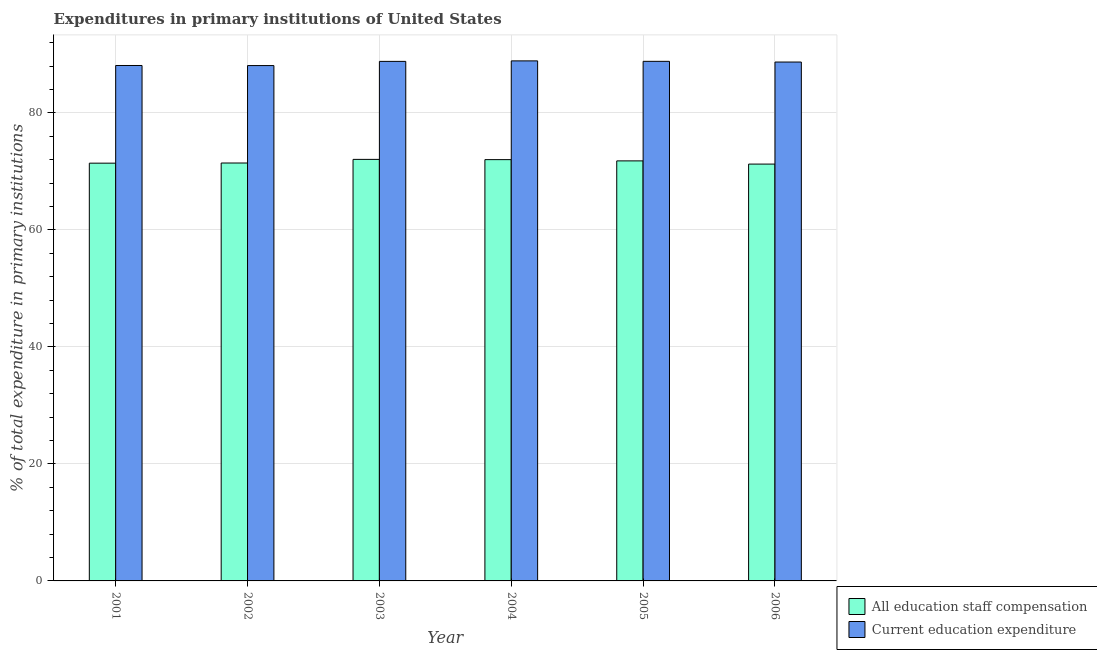How many different coloured bars are there?
Your answer should be very brief. 2. How many bars are there on the 4th tick from the right?
Provide a short and direct response. 2. What is the label of the 1st group of bars from the left?
Make the answer very short. 2001. In how many cases, is the number of bars for a given year not equal to the number of legend labels?
Offer a very short reply. 0. What is the expenditure in education in 2001?
Provide a short and direct response. 88.1. Across all years, what is the maximum expenditure in education?
Your answer should be compact. 88.89. Across all years, what is the minimum expenditure in education?
Your answer should be compact. 88.09. In which year was the expenditure in staff compensation maximum?
Provide a succinct answer. 2003. In which year was the expenditure in staff compensation minimum?
Provide a short and direct response. 2006. What is the total expenditure in staff compensation in the graph?
Your answer should be very brief. 429.93. What is the difference between the expenditure in staff compensation in 2003 and that in 2004?
Make the answer very short. 0.04. What is the difference between the expenditure in education in 2001 and the expenditure in staff compensation in 2002?
Your answer should be compact. 0.01. What is the average expenditure in staff compensation per year?
Offer a terse response. 71.66. In the year 2005, what is the difference between the expenditure in staff compensation and expenditure in education?
Offer a terse response. 0. What is the ratio of the expenditure in staff compensation in 2002 to that in 2004?
Give a very brief answer. 0.99. Is the expenditure in staff compensation in 2002 less than that in 2003?
Your answer should be very brief. Yes. What is the difference between the highest and the second highest expenditure in staff compensation?
Provide a succinct answer. 0.04. What is the difference between the highest and the lowest expenditure in staff compensation?
Make the answer very short. 0.8. In how many years, is the expenditure in education greater than the average expenditure in education taken over all years?
Your response must be concise. 4. What does the 1st bar from the left in 2002 represents?
Give a very brief answer. All education staff compensation. What does the 1st bar from the right in 2001 represents?
Ensure brevity in your answer.  Current education expenditure. What is the difference between two consecutive major ticks on the Y-axis?
Keep it short and to the point. 20. Are the values on the major ticks of Y-axis written in scientific E-notation?
Your answer should be compact. No. Does the graph contain any zero values?
Your response must be concise. No. How many legend labels are there?
Keep it short and to the point. 2. What is the title of the graph?
Offer a terse response. Expenditures in primary institutions of United States. Does "Under-five" appear as one of the legend labels in the graph?
Offer a very short reply. No. What is the label or title of the X-axis?
Your answer should be compact. Year. What is the label or title of the Y-axis?
Your answer should be compact. % of total expenditure in primary institutions. What is the % of total expenditure in primary institutions in All education staff compensation in 2001?
Your answer should be very brief. 71.4. What is the % of total expenditure in primary institutions in Current education expenditure in 2001?
Your answer should be compact. 88.1. What is the % of total expenditure in primary institutions of All education staff compensation in 2002?
Offer a very short reply. 71.43. What is the % of total expenditure in primary institutions of Current education expenditure in 2002?
Provide a short and direct response. 88.09. What is the % of total expenditure in primary institutions in All education staff compensation in 2003?
Give a very brief answer. 72.05. What is the % of total expenditure in primary institutions in Current education expenditure in 2003?
Your answer should be very brief. 88.8. What is the % of total expenditure in primary institutions in All education staff compensation in 2004?
Provide a succinct answer. 72.01. What is the % of total expenditure in primary institutions of Current education expenditure in 2004?
Provide a short and direct response. 88.89. What is the % of total expenditure in primary institutions of All education staff compensation in 2005?
Your answer should be very brief. 71.79. What is the % of total expenditure in primary institutions of Current education expenditure in 2005?
Your response must be concise. 88.81. What is the % of total expenditure in primary institutions of All education staff compensation in 2006?
Provide a succinct answer. 71.25. What is the % of total expenditure in primary institutions of Current education expenditure in 2006?
Provide a short and direct response. 88.69. Across all years, what is the maximum % of total expenditure in primary institutions of All education staff compensation?
Provide a short and direct response. 72.05. Across all years, what is the maximum % of total expenditure in primary institutions of Current education expenditure?
Offer a very short reply. 88.89. Across all years, what is the minimum % of total expenditure in primary institutions in All education staff compensation?
Your answer should be compact. 71.25. Across all years, what is the minimum % of total expenditure in primary institutions in Current education expenditure?
Your answer should be compact. 88.09. What is the total % of total expenditure in primary institutions in All education staff compensation in the graph?
Make the answer very short. 429.93. What is the total % of total expenditure in primary institutions of Current education expenditure in the graph?
Provide a short and direct response. 531.37. What is the difference between the % of total expenditure in primary institutions of All education staff compensation in 2001 and that in 2002?
Keep it short and to the point. -0.03. What is the difference between the % of total expenditure in primary institutions of Current education expenditure in 2001 and that in 2002?
Your answer should be very brief. 0.01. What is the difference between the % of total expenditure in primary institutions of All education staff compensation in 2001 and that in 2003?
Keep it short and to the point. -0.65. What is the difference between the % of total expenditure in primary institutions of Current education expenditure in 2001 and that in 2003?
Keep it short and to the point. -0.7. What is the difference between the % of total expenditure in primary institutions in All education staff compensation in 2001 and that in 2004?
Keep it short and to the point. -0.6. What is the difference between the % of total expenditure in primary institutions of Current education expenditure in 2001 and that in 2004?
Give a very brief answer. -0.79. What is the difference between the % of total expenditure in primary institutions in All education staff compensation in 2001 and that in 2005?
Keep it short and to the point. -0.39. What is the difference between the % of total expenditure in primary institutions in Current education expenditure in 2001 and that in 2005?
Your response must be concise. -0.71. What is the difference between the % of total expenditure in primary institutions in All education staff compensation in 2001 and that in 2006?
Your response must be concise. 0.16. What is the difference between the % of total expenditure in primary institutions in Current education expenditure in 2001 and that in 2006?
Your response must be concise. -0.59. What is the difference between the % of total expenditure in primary institutions of All education staff compensation in 2002 and that in 2003?
Provide a short and direct response. -0.62. What is the difference between the % of total expenditure in primary institutions in Current education expenditure in 2002 and that in 2003?
Keep it short and to the point. -0.71. What is the difference between the % of total expenditure in primary institutions in All education staff compensation in 2002 and that in 2004?
Offer a very short reply. -0.57. What is the difference between the % of total expenditure in primary institutions of Current education expenditure in 2002 and that in 2004?
Your answer should be very brief. -0.8. What is the difference between the % of total expenditure in primary institutions of All education staff compensation in 2002 and that in 2005?
Ensure brevity in your answer.  -0.36. What is the difference between the % of total expenditure in primary institutions of Current education expenditure in 2002 and that in 2005?
Your response must be concise. -0.72. What is the difference between the % of total expenditure in primary institutions of All education staff compensation in 2002 and that in 2006?
Your response must be concise. 0.18. What is the difference between the % of total expenditure in primary institutions of Current education expenditure in 2002 and that in 2006?
Provide a short and direct response. -0.6. What is the difference between the % of total expenditure in primary institutions of All education staff compensation in 2003 and that in 2004?
Give a very brief answer. 0.04. What is the difference between the % of total expenditure in primary institutions in Current education expenditure in 2003 and that in 2004?
Provide a succinct answer. -0.09. What is the difference between the % of total expenditure in primary institutions of All education staff compensation in 2003 and that in 2005?
Make the answer very short. 0.26. What is the difference between the % of total expenditure in primary institutions of Current education expenditure in 2003 and that in 2005?
Give a very brief answer. -0.01. What is the difference between the % of total expenditure in primary institutions in All education staff compensation in 2003 and that in 2006?
Give a very brief answer. 0.8. What is the difference between the % of total expenditure in primary institutions in Current education expenditure in 2003 and that in 2006?
Your answer should be very brief. 0.11. What is the difference between the % of total expenditure in primary institutions in All education staff compensation in 2004 and that in 2005?
Offer a very short reply. 0.21. What is the difference between the % of total expenditure in primary institutions of Current education expenditure in 2004 and that in 2005?
Give a very brief answer. 0.08. What is the difference between the % of total expenditure in primary institutions of All education staff compensation in 2004 and that in 2006?
Keep it short and to the point. 0.76. What is the difference between the % of total expenditure in primary institutions of Current education expenditure in 2004 and that in 2006?
Offer a very short reply. 0.2. What is the difference between the % of total expenditure in primary institutions of All education staff compensation in 2005 and that in 2006?
Your answer should be very brief. 0.55. What is the difference between the % of total expenditure in primary institutions in Current education expenditure in 2005 and that in 2006?
Offer a very short reply. 0.12. What is the difference between the % of total expenditure in primary institutions of All education staff compensation in 2001 and the % of total expenditure in primary institutions of Current education expenditure in 2002?
Your response must be concise. -16.68. What is the difference between the % of total expenditure in primary institutions in All education staff compensation in 2001 and the % of total expenditure in primary institutions in Current education expenditure in 2003?
Your response must be concise. -17.4. What is the difference between the % of total expenditure in primary institutions of All education staff compensation in 2001 and the % of total expenditure in primary institutions of Current education expenditure in 2004?
Give a very brief answer. -17.48. What is the difference between the % of total expenditure in primary institutions in All education staff compensation in 2001 and the % of total expenditure in primary institutions in Current education expenditure in 2005?
Ensure brevity in your answer.  -17.4. What is the difference between the % of total expenditure in primary institutions of All education staff compensation in 2001 and the % of total expenditure in primary institutions of Current education expenditure in 2006?
Make the answer very short. -17.28. What is the difference between the % of total expenditure in primary institutions in All education staff compensation in 2002 and the % of total expenditure in primary institutions in Current education expenditure in 2003?
Ensure brevity in your answer.  -17.37. What is the difference between the % of total expenditure in primary institutions of All education staff compensation in 2002 and the % of total expenditure in primary institutions of Current education expenditure in 2004?
Make the answer very short. -17.46. What is the difference between the % of total expenditure in primary institutions in All education staff compensation in 2002 and the % of total expenditure in primary institutions in Current education expenditure in 2005?
Keep it short and to the point. -17.38. What is the difference between the % of total expenditure in primary institutions in All education staff compensation in 2002 and the % of total expenditure in primary institutions in Current education expenditure in 2006?
Keep it short and to the point. -17.26. What is the difference between the % of total expenditure in primary institutions in All education staff compensation in 2003 and the % of total expenditure in primary institutions in Current education expenditure in 2004?
Offer a terse response. -16.84. What is the difference between the % of total expenditure in primary institutions of All education staff compensation in 2003 and the % of total expenditure in primary institutions of Current education expenditure in 2005?
Provide a short and direct response. -16.76. What is the difference between the % of total expenditure in primary institutions of All education staff compensation in 2003 and the % of total expenditure in primary institutions of Current education expenditure in 2006?
Make the answer very short. -16.64. What is the difference between the % of total expenditure in primary institutions of All education staff compensation in 2004 and the % of total expenditure in primary institutions of Current education expenditure in 2005?
Make the answer very short. -16.8. What is the difference between the % of total expenditure in primary institutions in All education staff compensation in 2004 and the % of total expenditure in primary institutions in Current education expenditure in 2006?
Give a very brief answer. -16.68. What is the difference between the % of total expenditure in primary institutions in All education staff compensation in 2005 and the % of total expenditure in primary institutions in Current education expenditure in 2006?
Your response must be concise. -16.89. What is the average % of total expenditure in primary institutions in All education staff compensation per year?
Offer a terse response. 71.66. What is the average % of total expenditure in primary institutions in Current education expenditure per year?
Your answer should be compact. 88.56. In the year 2001, what is the difference between the % of total expenditure in primary institutions in All education staff compensation and % of total expenditure in primary institutions in Current education expenditure?
Provide a succinct answer. -16.7. In the year 2002, what is the difference between the % of total expenditure in primary institutions of All education staff compensation and % of total expenditure in primary institutions of Current education expenditure?
Provide a succinct answer. -16.65. In the year 2003, what is the difference between the % of total expenditure in primary institutions of All education staff compensation and % of total expenditure in primary institutions of Current education expenditure?
Ensure brevity in your answer.  -16.75. In the year 2004, what is the difference between the % of total expenditure in primary institutions of All education staff compensation and % of total expenditure in primary institutions of Current education expenditure?
Offer a very short reply. -16.88. In the year 2005, what is the difference between the % of total expenditure in primary institutions in All education staff compensation and % of total expenditure in primary institutions in Current education expenditure?
Offer a terse response. -17.01. In the year 2006, what is the difference between the % of total expenditure in primary institutions in All education staff compensation and % of total expenditure in primary institutions in Current education expenditure?
Your answer should be very brief. -17.44. What is the ratio of the % of total expenditure in primary institutions in All education staff compensation in 2001 to that in 2002?
Make the answer very short. 1. What is the ratio of the % of total expenditure in primary institutions in Current education expenditure in 2001 to that in 2006?
Make the answer very short. 0.99. What is the ratio of the % of total expenditure in primary institutions in All education staff compensation in 2002 to that in 2003?
Make the answer very short. 0.99. What is the ratio of the % of total expenditure in primary institutions of All education staff compensation in 2002 to that in 2004?
Your response must be concise. 0.99. What is the ratio of the % of total expenditure in primary institutions of Current education expenditure in 2002 to that in 2004?
Keep it short and to the point. 0.99. What is the ratio of the % of total expenditure in primary institutions in All education staff compensation in 2003 to that in 2004?
Your response must be concise. 1. What is the ratio of the % of total expenditure in primary institutions in Current education expenditure in 2003 to that in 2004?
Your answer should be very brief. 1. What is the ratio of the % of total expenditure in primary institutions of All education staff compensation in 2003 to that in 2006?
Provide a succinct answer. 1.01. What is the ratio of the % of total expenditure in primary institutions in Current education expenditure in 2003 to that in 2006?
Provide a short and direct response. 1. What is the ratio of the % of total expenditure in primary institutions of All education staff compensation in 2004 to that in 2005?
Provide a succinct answer. 1. What is the ratio of the % of total expenditure in primary institutions of All education staff compensation in 2004 to that in 2006?
Provide a short and direct response. 1.01. What is the ratio of the % of total expenditure in primary institutions of All education staff compensation in 2005 to that in 2006?
Your answer should be very brief. 1.01. What is the ratio of the % of total expenditure in primary institutions of Current education expenditure in 2005 to that in 2006?
Your response must be concise. 1. What is the difference between the highest and the second highest % of total expenditure in primary institutions of All education staff compensation?
Your answer should be very brief. 0.04. What is the difference between the highest and the second highest % of total expenditure in primary institutions of Current education expenditure?
Give a very brief answer. 0.08. What is the difference between the highest and the lowest % of total expenditure in primary institutions in All education staff compensation?
Give a very brief answer. 0.8. What is the difference between the highest and the lowest % of total expenditure in primary institutions of Current education expenditure?
Provide a short and direct response. 0.8. 